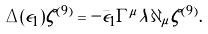<formula> <loc_0><loc_0><loc_500><loc_500>\Delta ( \epsilon _ { 1 } ) \zeta ^ { ( 9 ) } = - \bar { \epsilon } _ { 1 } \Gamma ^ { \mu } \lambda \partial _ { \mu } \zeta ^ { ( 9 ) } .</formula> 